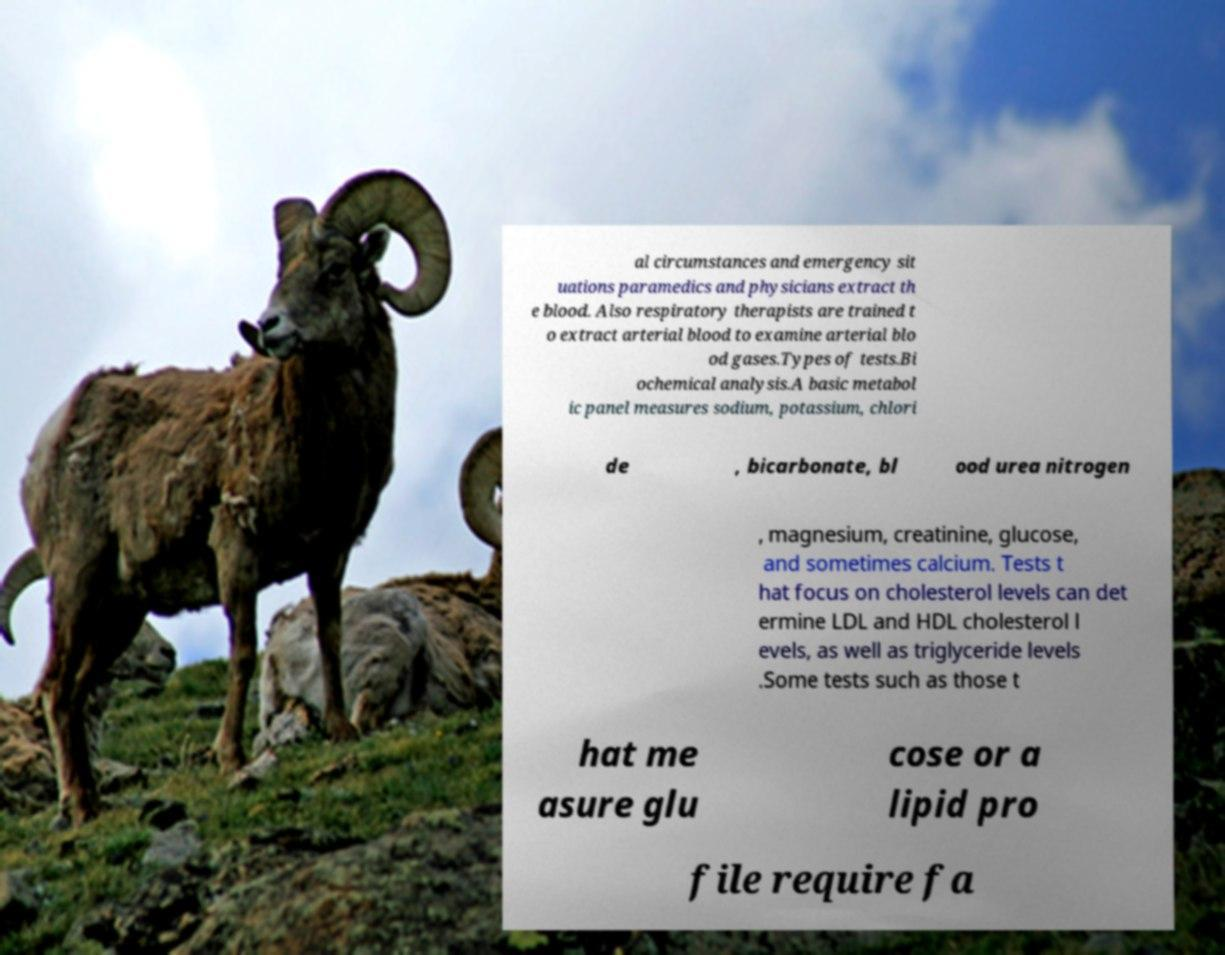Can you read and provide the text displayed in the image?This photo seems to have some interesting text. Can you extract and type it out for me? al circumstances and emergency sit uations paramedics and physicians extract th e blood. Also respiratory therapists are trained t o extract arterial blood to examine arterial blo od gases.Types of tests.Bi ochemical analysis.A basic metabol ic panel measures sodium, potassium, chlori de , bicarbonate, bl ood urea nitrogen , magnesium, creatinine, glucose, and sometimes calcium. Tests t hat focus on cholesterol levels can det ermine LDL and HDL cholesterol l evels, as well as triglyceride levels .Some tests such as those t hat me asure glu cose or a lipid pro file require fa 